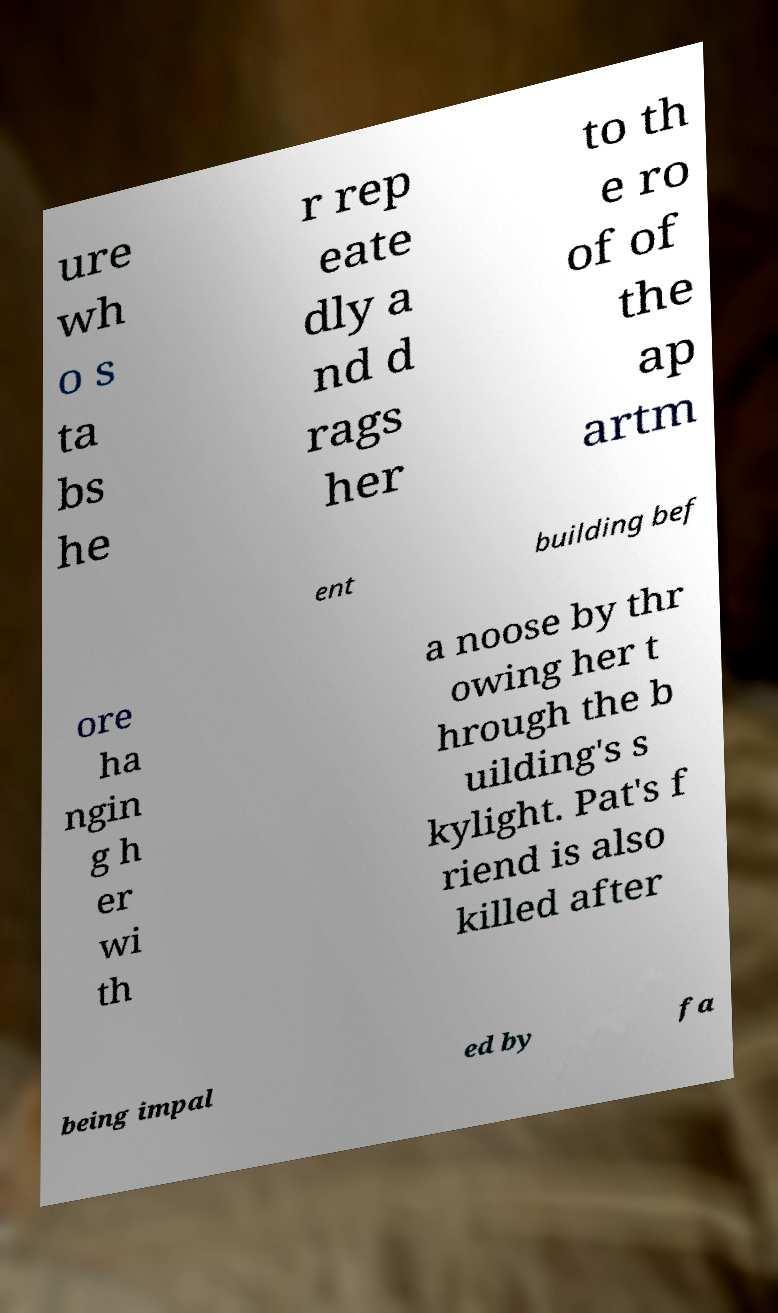For documentation purposes, I need the text within this image transcribed. Could you provide that? ure wh o s ta bs he r rep eate dly a nd d rags her to th e ro of of the ap artm ent building bef ore ha ngin g h er wi th a noose by thr owing her t hrough the b uilding's s kylight. Pat's f riend is also killed after being impal ed by fa 